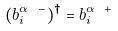<formula> <loc_0><loc_0><loc_500><loc_500>( b _ { i } ^ { \alpha \ - } ) ^ { \dagger } = b _ { i } ^ { \alpha \ + }</formula> 